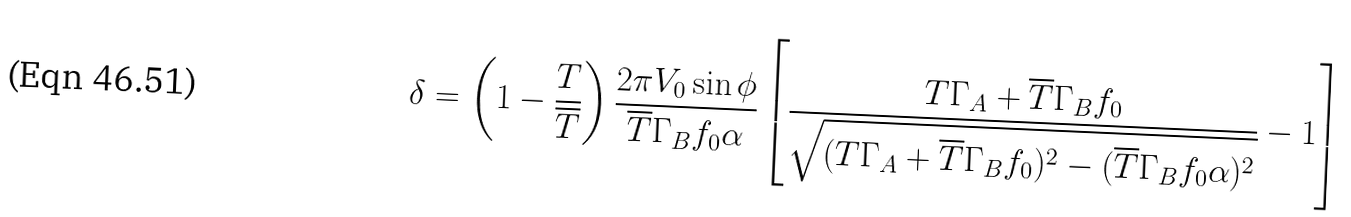Convert formula to latex. <formula><loc_0><loc_0><loc_500><loc_500>\delta = \left ( 1 - \frac { T } { \overline { T } } \right ) \frac { 2 \pi V _ { 0 } \sin \phi } { { \overline { T } } \Gamma _ { B } f _ { 0 } \alpha } \left [ \frac { T \Gamma _ { A } + { \overline { T } } \Gamma _ { B } f _ { 0 } } { \sqrt { ( T \Gamma _ { A } + { \overline { T } } \Gamma _ { B } f _ { 0 } ) ^ { 2 } - ( { \overline { T } } \Gamma _ { B } f _ { 0 } \alpha ) ^ { 2 } } } - 1 \right ]</formula> 